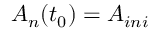<formula> <loc_0><loc_0><loc_500><loc_500>A _ { n } ( t _ { 0 } ) = A _ { i n i }</formula> 